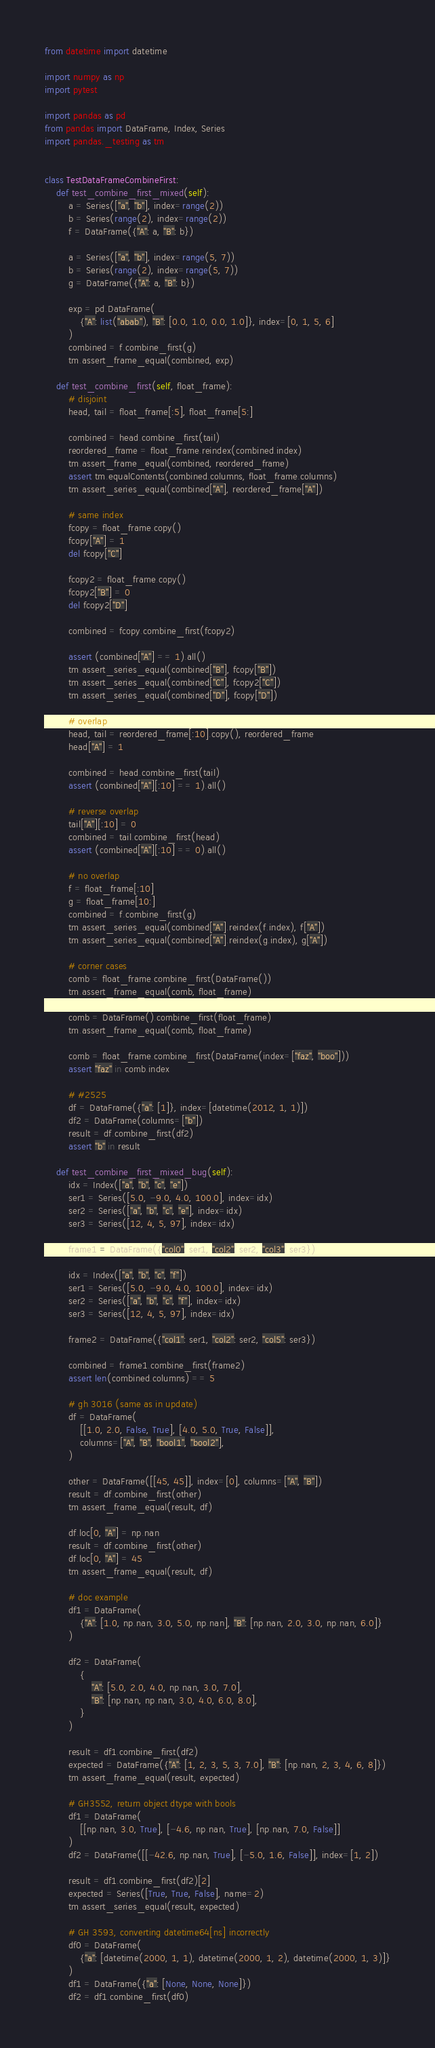<code> <loc_0><loc_0><loc_500><loc_500><_Python_>from datetime import datetime

import numpy as np
import pytest

import pandas as pd
from pandas import DataFrame, Index, Series
import pandas._testing as tm


class TestDataFrameCombineFirst:
    def test_combine_first_mixed(self):
        a = Series(["a", "b"], index=range(2))
        b = Series(range(2), index=range(2))
        f = DataFrame({"A": a, "B": b})

        a = Series(["a", "b"], index=range(5, 7))
        b = Series(range(2), index=range(5, 7))
        g = DataFrame({"A": a, "B": b})

        exp = pd.DataFrame(
            {"A": list("abab"), "B": [0.0, 1.0, 0.0, 1.0]}, index=[0, 1, 5, 6]
        )
        combined = f.combine_first(g)
        tm.assert_frame_equal(combined, exp)

    def test_combine_first(self, float_frame):
        # disjoint
        head, tail = float_frame[:5], float_frame[5:]

        combined = head.combine_first(tail)
        reordered_frame = float_frame.reindex(combined.index)
        tm.assert_frame_equal(combined, reordered_frame)
        assert tm.equalContents(combined.columns, float_frame.columns)
        tm.assert_series_equal(combined["A"], reordered_frame["A"])

        # same index
        fcopy = float_frame.copy()
        fcopy["A"] = 1
        del fcopy["C"]

        fcopy2 = float_frame.copy()
        fcopy2["B"] = 0
        del fcopy2["D"]

        combined = fcopy.combine_first(fcopy2)

        assert (combined["A"] == 1).all()
        tm.assert_series_equal(combined["B"], fcopy["B"])
        tm.assert_series_equal(combined["C"], fcopy2["C"])
        tm.assert_series_equal(combined["D"], fcopy["D"])

        # overlap
        head, tail = reordered_frame[:10].copy(), reordered_frame
        head["A"] = 1

        combined = head.combine_first(tail)
        assert (combined["A"][:10] == 1).all()

        # reverse overlap
        tail["A"][:10] = 0
        combined = tail.combine_first(head)
        assert (combined["A"][:10] == 0).all()

        # no overlap
        f = float_frame[:10]
        g = float_frame[10:]
        combined = f.combine_first(g)
        tm.assert_series_equal(combined["A"].reindex(f.index), f["A"])
        tm.assert_series_equal(combined["A"].reindex(g.index), g["A"])

        # corner cases
        comb = float_frame.combine_first(DataFrame())
        tm.assert_frame_equal(comb, float_frame)

        comb = DataFrame().combine_first(float_frame)
        tm.assert_frame_equal(comb, float_frame)

        comb = float_frame.combine_first(DataFrame(index=["faz", "boo"]))
        assert "faz" in comb.index

        # #2525
        df = DataFrame({"a": [1]}, index=[datetime(2012, 1, 1)])
        df2 = DataFrame(columns=["b"])
        result = df.combine_first(df2)
        assert "b" in result

    def test_combine_first_mixed_bug(self):
        idx = Index(["a", "b", "c", "e"])
        ser1 = Series([5.0, -9.0, 4.0, 100.0], index=idx)
        ser2 = Series(["a", "b", "c", "e"], index=idx)
        ser3 = Series([12, 4, 5, 97], index=idx)

        frame1 = DataFrame({"col0": ser1, "col2": ser2, "col3": ser3})

        idx = Index(["a", "b", "c", "f"])
        ser1 = Series([5.0, -9.0, 4.0, 100.0], index=idx)
        ser2 = Series(["a", "b", "c", "f"], index=idx)
        ser3 = Series([12, 4, 5, 97], index=idx)

        frame2 = DataFrame({"col1": ser1, "col2": ser2, "col5": ser3})

        combined = frame1.combine_first(frame2)
        assert len(combined.columns) == 5

        # gh 3016 (same as in update)
        df = DataFrame(
            [[1.0, 2.0, False, True], [4.0, 5.0, True, False]],
            columns=["A", "B", "bool1", "bool2"],
        )

        other = DataFrame([[45, 45]], index=[0], columns=["A", "B"])
        result = df.combine_first(other)
        tm.assert_frame_equal(result, df)

        df.loc[0, "A"] = np.nan
        result = df.combine_first(other)
        df.loc[0, "A"] = 45
        tm.assert_frame_equal(result, df)

        # doc example
        df1 = DataFrame(
            {"A": [1.0, np.nan, 3.0, 5.0, np.nan], "B": [np.nan, 2.0, 3.0, np.nan, 6.0]}
        )

        df2 = DataFrame(
            {
                "A": [5.0, 2.0, 4.0, np.nan, 3.0, 7.0],
                "B": [np.nan, np.nan, 3.0, 4.0, 6.0, 8.0],
            }
        )

        result = df1.combine_first(df2)
        expected = DataFrame({"A": [1, 2, 3, 5, 3, 7.0], "B": [np.nan, 2, 3, 4, 6, 8]})
        tm.assert_frame_equal(result, expected)

        # GH3552, return object dtype with bools
        df1 = DataFrame(
            [[np.nan, 3.0, True], [-4.6, np.nan, True], [np.nan, 7.0, False]]
        )
        df2 = DataFrame([[-42.6, np.nan, True], [-5.0, 1.6, False]], index=[1, 2])

        result = df1.combine_first(df2)[2]
        expected = Series([True, True, False], name=2)
        tm.assert_series_equal(result, expected)

        # GH 3593, converting datetime64[ns] incorrectly
        df0 = DataFrame(
            {"a": [datetime(2000, 1, 1), datetime(2000, 1, 2), datetime(2000, 1, 3)]}
        )
        df1 = DataFrame({"a": [None, None, None]})
        df2 = df1.combine_first(df0)</code> 